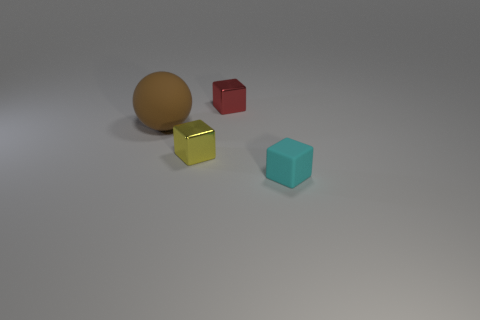Subtract all cyan matte blocks. How many blocks are left? 2 Subtract all blocks. How many objects are left? 1 Add 2 metallic things. How many metallic things are left? 4 Add 1 cyan cubes. How many cyan cubes exist? 2 Add 3 big things. How many objects exist? 7 Subtract all red cubes. How many cubes are left? 2 Subtract 0 red cylinders. How many objects are left? 4 Subtract 1 balls. How many balls are left? 0 Subtract all cyan blocks. Subtract all purple cylinders. How many blocks are left? 2 Subtract all yellow balls. How many blue blocks are left? 0 